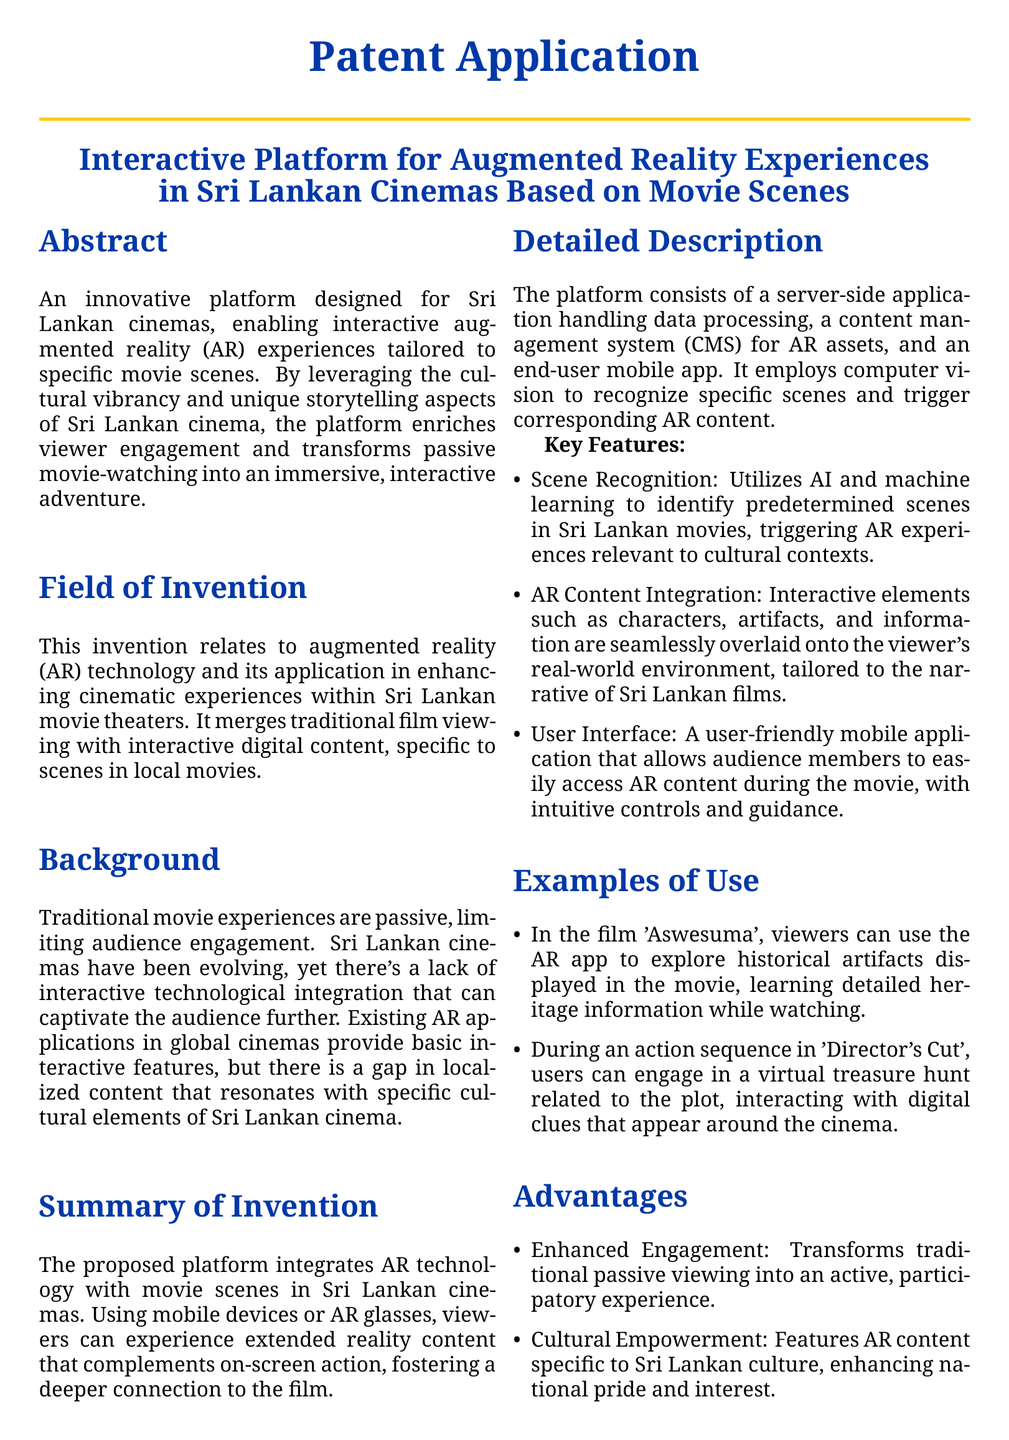What is the title of the patent application? The title is presented prominently in the document, summarizing the invention related to augmented reality in cinemas.
Answer: Interactive Platform for Augmented Reality Experiences in Sri Lankan Cinemas Based on Movie Scenes What technology does the invention utilize? The document specifies the main technology involved in enhancing cinema experiences.
Answer: Augmented reality Which foreign film is mentioned as an example in the document? The examples include specific films that showcase how the platform can be utilized; one of them is given here.
Answer: Aswesuma What key feature utilizes AI and machine learning? The document lists features that enhance the interactive experience, including one based on advanced technology.
Answer: Scene Recognition How many claims are made in the patent application? The claims section outlines specific assertions related to the invention, stating a numerical count.
Answer: Two claims What is one of the advantages of the proposed platform? The advantages section highlights several benefits; one of them is key to viewer engagement.
Answer: Enhanced Engagement What does CMS stand for in the context of the platform? The document describes components of the platform, detailing its content management system’s abbreviation.
Answer: Content Management System What is the primary goal of integrating AR technology with cinema? The document outlines the intention behind the invention in terms of viewer engagement levels.
Answer: Transforming passive movie-watching into an immersive, interactive adventure What type of mobile devices can users employ for the platform? The description specifies the kind of devices that viewers can utilize with the technology presented.
Answer: Mobile devices or AR glasses 